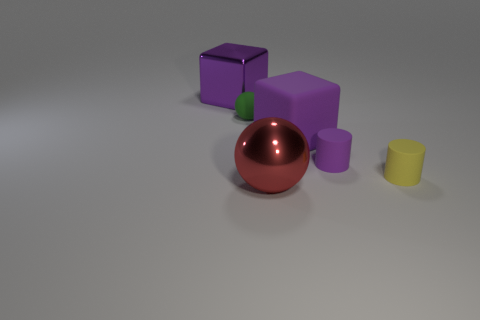What size is the shiny object that is on the left side of the matte sphere?
Offer a terse response. Large. The other cube that is the same color as the metallic cube is what size?
Offer a terse response. Large. Is there a small red object made of the same material as the purple cylinder?
Provide a short and direct response. No. Is the small green object made of the same material as the tiny purple thing?
Your answer should be compact. Yes. There is a rubber cylinder that is the same size as the yellow thing; what color is it?
Offer a very short reply. Purple. How many other things are the same shape as the red thing?
Your answer should be compact. 1. There is a red shiny ball; is it the same size as the purple object in front of the big rubber object?
Ensure brevity in your answer.  No. How many objects are tiny blue metallic cylinders or rubber cylinders?
Ensure brevity in your answer.  2. How many other things are there of the same size as the shiny ball?
Ensure brevity in your answer.  2. Is the color of the big matte block the same as the big thing that is left of the large sphere?
Your answer should be very brief. Yes. 